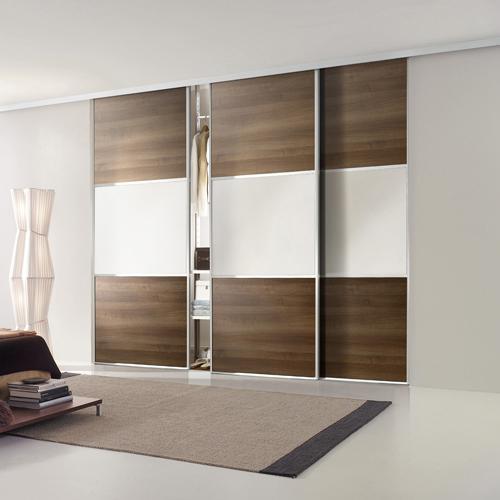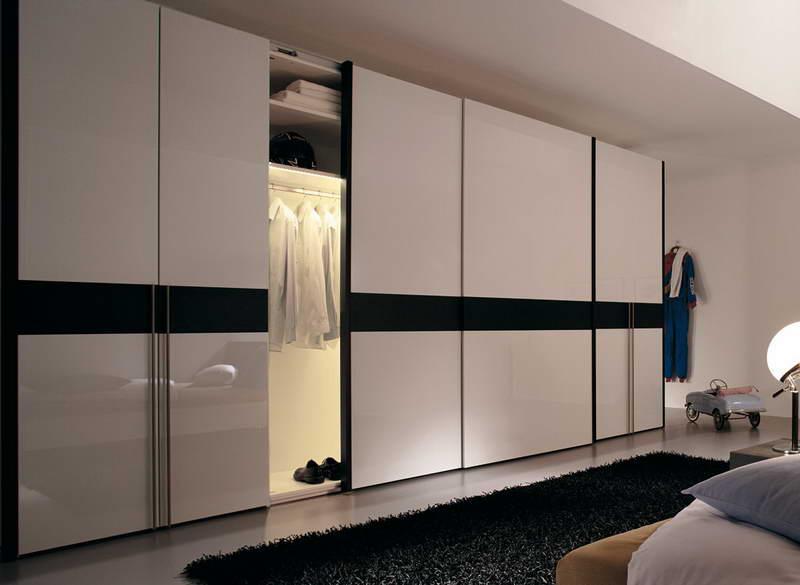The first image is the image on the left, the second image is the image on the right. Given the left and right images, does the statement "Both closets are closed." hold true? Answer yes or no. No. The first image is the image on the left, the second image is the image on the right. Assess this claim about the two images: "The left image shows a unit with three sliding doors and a band across the front surrounded by a brown top and bottom.". Correct or not? Answer yes or no. Yes. 